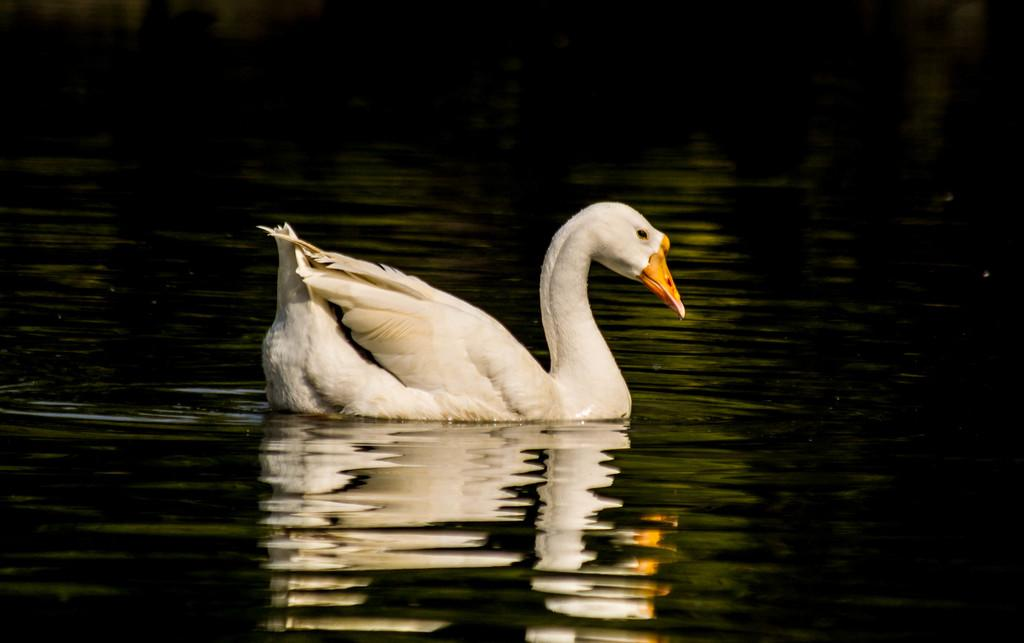What animal can be seen in the image? There is a swan in the image. What is the swan doing in the image? The swan is swimming in the water. What color is the water in the image? The water is white in color. Can you describe the background of the image? There is water visible in the background of the image. How many yards of fabric are used to create the base of the swan in the image? There is no fabric or base present in the image; it is a swan swimming in water. 